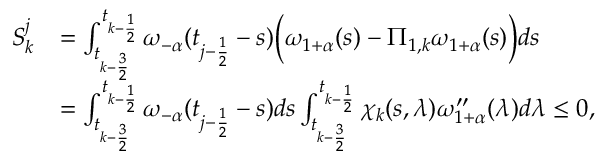<formula> <loc_0><loc_0><loc_500><loc_500>\begin{array} { r l } { S _ { k } ^ { j } } & { = \int _ { t _ { k - \frac { 3 } { 2 } } } ^ { t _ { k - \frac { 1 } { 2 } } } \omega _ { - \alpha } ( t _ { j - \frac { 1 } { 2 } } - s ) \left ( \omega _ { 1 + \alpha } ( s ) - \Pi _ { 1 , k } \omega _ { 1 + \alpha } ( s ) \right ) d s } \\ & { = \int _ { t _ { k - \frac { 3 } { 2 } } } ^ { t _ { k - \frac { 1 } { 2 } } } \omega _ { - \alpha } ( t _ { j - \frac { 1 } { 2 } } - s ) d s \int _ { t _ { k - \frac { 3 } { 2 } } } ^ { t _ { k - \frac { 1 } { 2 } } } \chi _ { k } ( s , \lambda ) \omega _ { 1 + \alpha } ^ { \prime \prime } ( \lambda ) d \lambda \leq 0 , } \end{array}</formula> 